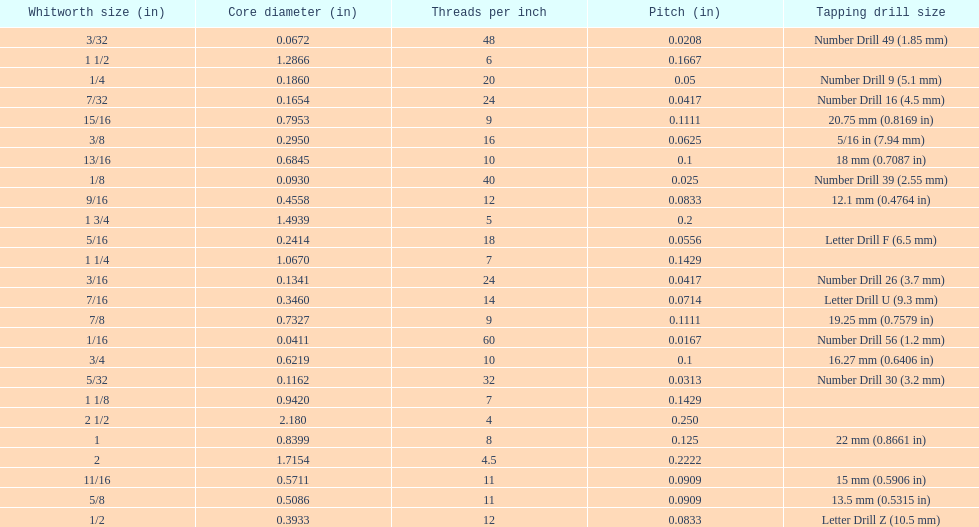What is the total of the first two core diameters? 0.1083. 